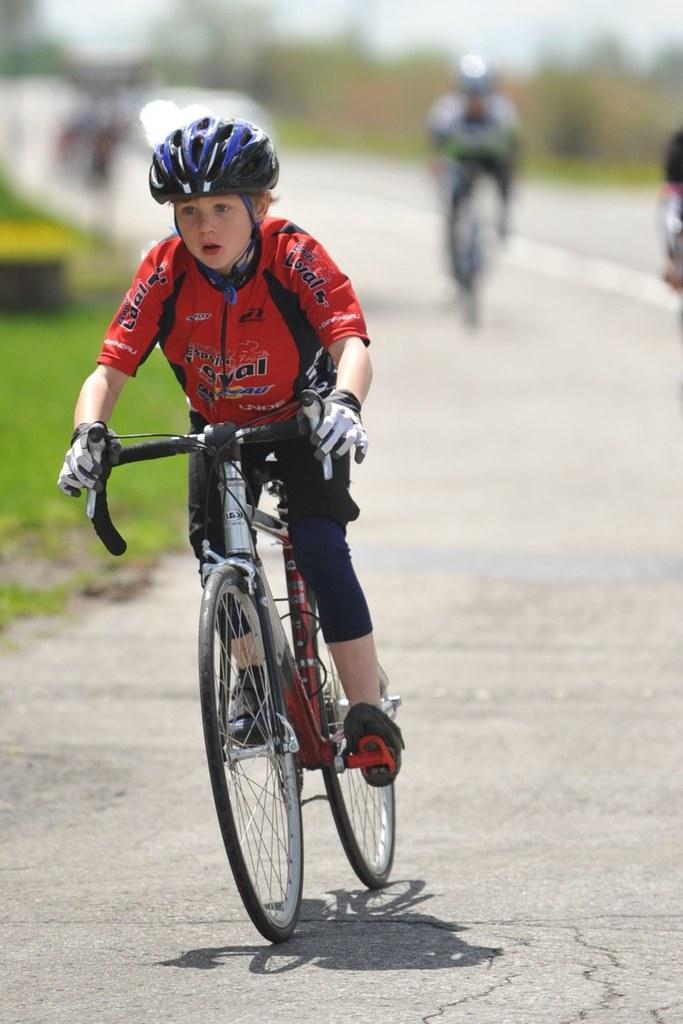Describe this image in one or two sentences. In this image we can see a boy is riding a bicycle and he wore a red color dress and a helmet. Background of the image is in a blur. 